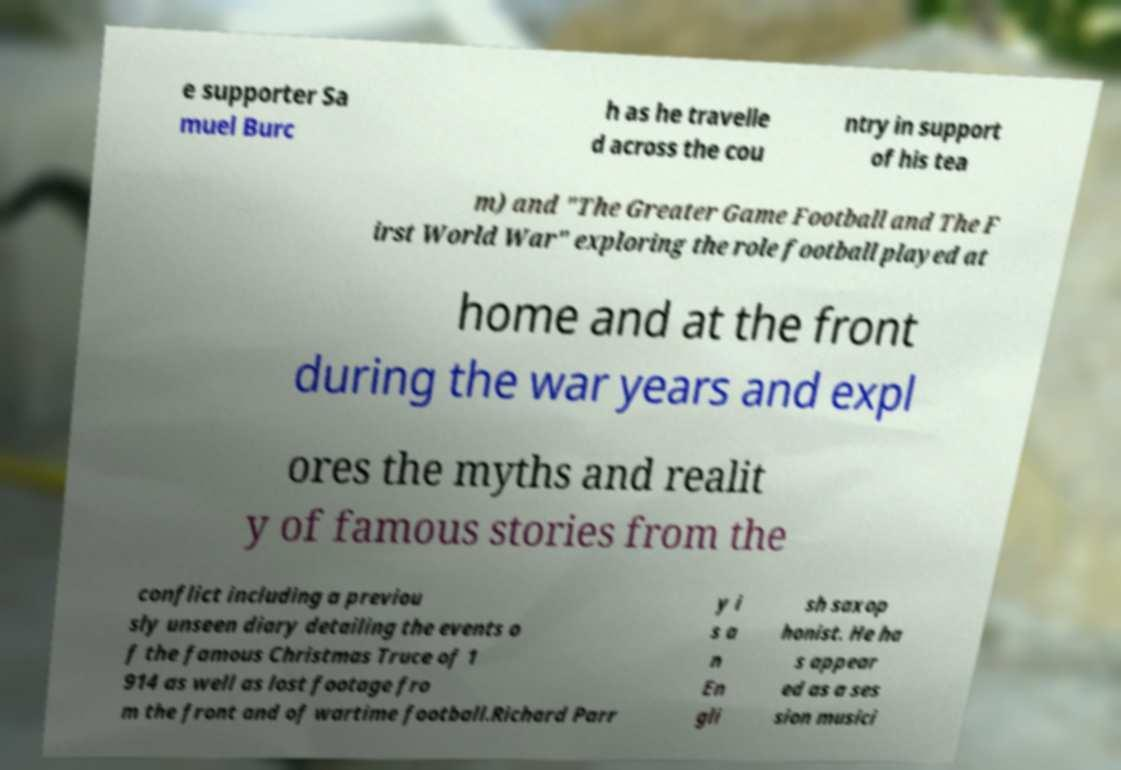I need the written content from this picture converted into text. Can you do that? e supporter Sa muel Burc h as he travelle d across the cou ntry in support of his tea m) and "The Greater Game Football and The F irst World War" exploring the role football played at home and at the front during the war years and expl ores the myths and realit y of famous stories from the conflict including a previou sly unseen diary detailing the events o f the famous Christmas Truce of 1 914 as well as lost footage fro m the front and of wartime football.Richard Parr y i s a n En gli sh saxop honist. He ha s appear ed as a ses sion musici 